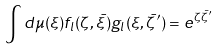Convert formula to latex. <formula><loc_0><loc_0><loc_500><loc_500>\int d \mu ( \xi ) f _ { l } ( \zeta , \bar { \xi } ) g _ { l } ( \xi , \bar { \zeta } ^ { \prime } ) = e ^ { \zeta \bar { \zeta } ^ { \prime } }</formula> 